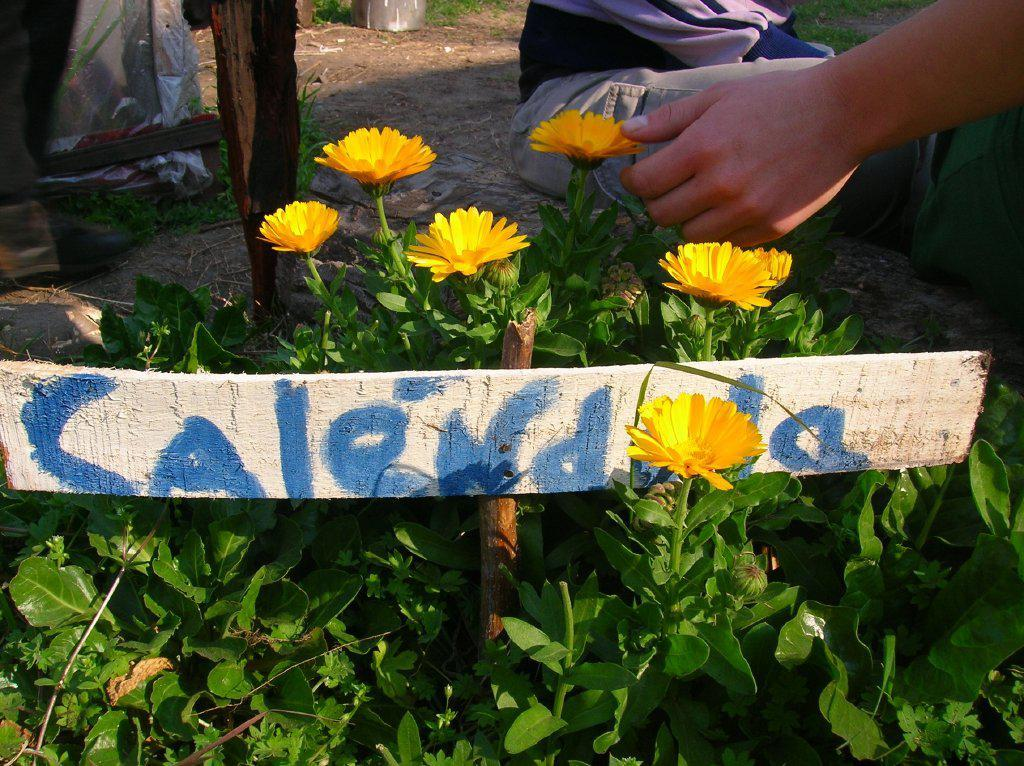What part of a person can be seen in the image? There is a person's hand in the image. What material is the board in the image made of? The wooden board in the image is made of wood. What type of plants are present in the image? There are plants with flowers in the image. What can be seen in the background of the image? There are objects on the ground in the background of the image. What type of whip is being used by the person in the image? There is no whip present in the image; it only shows a person's hand, a wooden board, plants with flowers, and objects on the ground in the background. 